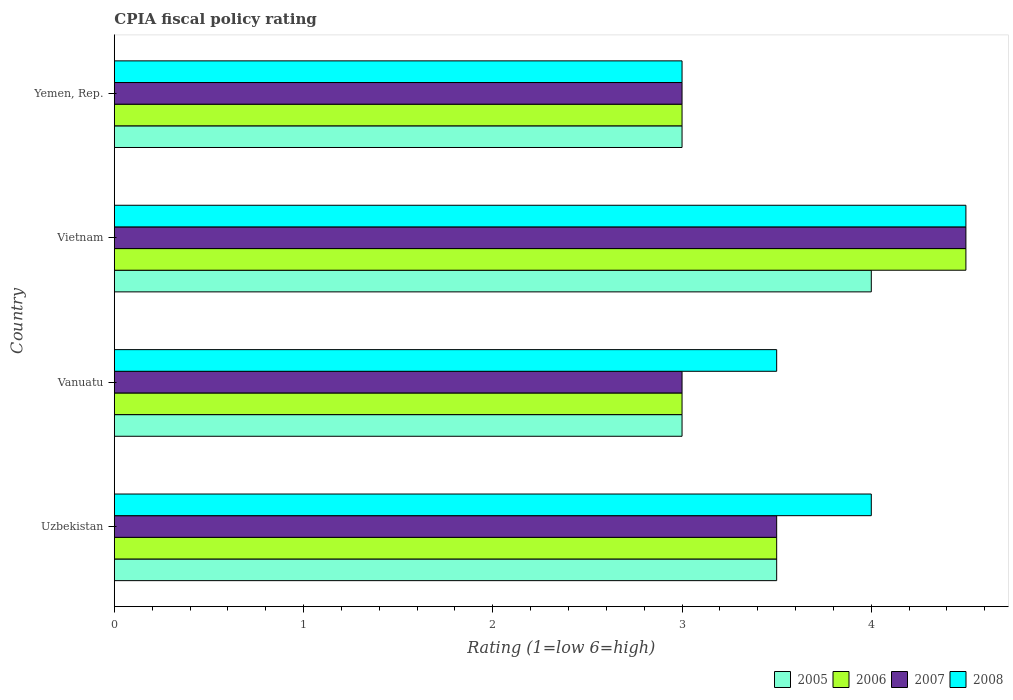How many groups of bars are there?
Make the answer very short. 4. How many bars are there on the 2nd tick from the top?
Your answer should be very brief. 4. How many bars are there on the 1st tick from the bottom?
Offer a very short reply. 4. What is the label of the 3rd group of bars from the top?
Offer a very short reply. Vanuatu. What is the CPIA rating in 2006 in Uzbekistan?
Keep it short and to the point. 3.5. Across all countries, what is the maximum CPIA rating in 2007?
Make the answer very short. 4.5. In which country was the CPIA rating in 2006 maximum?
Give a very brief answer. Vietnam. In which country was the CPIA rating in 2007 minimum?
Your response must be concise. Vanuatu. What is the difference between the CPIA rating in 2008 in Uzbekistan and the CPIA rating in 2006 in Vanuatu?
Make the answer very short. 1. What is the difference between the CPIA rating in 2005 and CPIA rating in 2008 in Vanuatu?
Provide a succinct answer. -0.5. What is the ratio of the CPIA rating in 2007 in Vanuatu to that in Yemen, Rep.?
Make the answer very short. 1. Is the CPIA rating in 2005 in Uzbekistan less than that in Yemen, Rep.?
Your answer should be very brief. No. Is the difference between the CPIA rating in 2005 in Uzbekistan and Yemen, Rep. greater than the difference between the CPIA rating in 2008 in Uzbekistan and Yemen, Rep.?
Make the answer very short. No. In how many countries, is the CPIA rating in 2005 greater than the average CPIA rating in 2005 taken over all countries?
Offer a terse response. 2. Is the sum of the CPIA rating in 2008 in Vanuatu and Vietnam greater than the maximum CPIA rating in 2006 across all countries?
Offer a terse response. Yes. Is it the case that in every country, the sum of the CPIA rating in 2007 and CPIA rating in 2006 is greater than the sum of CPIA rating in 2005 and CPIA rating in 2008?
Your answer should be compact. No. What does the 4th bar from the bottom in Vanuatu represents?
Ensure brevity in your answer.  2008. How many bars are there?
Offer a terse response. 16. Are all the bars in the graph horizontal?
Your response must be concise. Yes. How many countries are there in the graph?
Your answer should be very brief. 4. Does the graph contain any zero values?
Offer a very short reply. No. Does the graph contain grids?
Provide a succinct answer. No. Where does the legend appear in the graph?
Your answer should be compact. Bottom right. How are the legend labels stacked?
Give a very brief answer. Horizontal. What is the title of the graph?
Your response must be concise. CPIA fiscal policy rating. Does "1983" appear as one of the legend labels in the graph?
Your answer should be very brief. No. What is the label or title of the X-axis?
Your answer should be compact. Rating (1=low 6=high). What is the Rating (1=low 6=high) of 2005 in Uzbekistan?
Give a very brief answer. 3.5. What is the Rating (1=low 6=high) of 2005 in Vanuatu?
Give a very brief answer. 3. What is the Rating (1=low 6=high) in 2008 in Vanuatu?
Your answer should be compact. 3.5. What is the Rating (1=low 6=high) of 2007 in Vietnam?
Provide a short and direct response. 4.5. What is the Rating (1=low 6=high) of 2005 in Yemen, Rep.?
Ensure brevity in your answer.  3. What is the Rating (1=low 6=high) of 2007 in Yemen, Rep.?
Make the answer very short. 3. What is the Rating (1=low 6=high) of 2008 in Yemen, Rep.?
Provide a succinct answer. 3. Across all countries, what is the maximum Rating (1=low 6=high) of 2008?
Give a very brief answer. 4.5. Across all countries, what is the minimum Rating (1=low 6=high) in 2006?
Provide a succinct answer. 3. Across all countries, what is the minimum Rating (1=low 6=high) of 2007?
Give a very brief answer. 3. What is the total Rating (1=low 6=high) in 2005 in the graph?
Give a very brief answer. 13.5. What is the total Rating (1=low 6=high) in 2006 in the graph?
Offer a terse response. 14. What is the total Rating (1=low 6=high) in 2007 in the graph?
Offer a very short reply. 14. What is the difference between the Rating (1=low 6=high) in 2005 in Uzbekistan and that in Vanuatu?
Ensure brevity in your answer.  0.5. What is the difference between the Rating (1=low 6=high) in 2006 in Uzbekistan and that in Vanuatu?
Your response must be concise. 0.5. What is the difference between the Rating (1=low 6=high) in 2008 in Uzbekistan and that in Vanuatu?
Offer a terse response. 0.5. What is the difference between the Rating (1=low 6=high) of 2005 in Uzbekistan and that in Vietnam?
Keep it short and to the point. -0.5. What is the difference between the Rating (1=low 6=high) of 2007 in Uzbekistan and that in Vietnam?
Your answer should be very brief. -1. What is the difference between the Rating (1=low 6=high) of 2008 in Uzbekistan and that in Vietnam?
Provide a short and direct response. -0.5. What is the difference between the Rating (1=low 6=high) of 2005 in Uzbekistan and that in Yemen, Rep.?
Ensure brevity in your answer.  0.5. What is the difference between the Rating (1=low 6=high) of 2006 in Uzbekistan and that in Yemen, Rep.?
Your answer should be very brief. 0.5. What is the difference between the Rating (1=low 6=high) of 2007 in Uzbekistan and that in Yemen, Rep.?
Give a very brief answer. 0.5. What is the difference between the Rating (1=low 6=high) in 2005 in Vanuatu and that in Yemen, Rep.?
Your answer should be very brief. 0. What is the difference between the Rating (1=low 6=high) in 2006 in Vanuatu and that in Yemen, Rep.?
Provide a succinct answer. 0. What is the difference between the Rating (1=low 6=high) in 2007 in Vanuatu and that in Yemen, Rep.?
Your answer should be very brief. 0. What is the difference between the Rating (1=low 6=high) of 2005 in Vietnam and that in Yemen, Rep.?
Your response must be concise. 1. What is the difference between the Rating (1=low 6=high) in 2006 in Vietnam and that in Yemen, Rep.?
Give a very brief answer. 1.5. What is the difference between the Rating (1=low 6=high) in 2007 in Vietnam and that in Yemen, Rep.?
Your answer should be compact. 1.5. What is the difference between the Rating (1=low 6=high) of 2005 in Uzbekistan and the Rating (1=low 6=high) of 2006 in Vanuatu?
Make the answer very short. 0.5. What is the difference between the Rating (1=low 6=high) in 2005 in Uzbekistan and the Rating (1=low 6=high) in 2008 in Vanuatu?
Keep it short and to the point. 0. What is the difference between the Rating (1=low 6=high) in 2006 in Uzbekistan and the Rating (1=low 6=high) in 2008 in Vanuatu?
Ensure brevity in your answer.  0. What is the difference between the Rating (1=low 6=high) in 2007 in Uzbekistan and the Rating (1=low 6=high) in 2008 in Vanuatu?
Provide a short and direct response. 0. What is the difference between the Rating (1=low 6=high) of 2005 in Uzbekistan and the Rating (1=low 6=high) of 2008 in Vietnam?
Provide a short and direct response. -1. What is the difference between the Rating (1=low 6=high) of 2006 in Uzbekistan and the Rating (1=low 6=high) of 2007 in Vietnam?
Your response must be concise. -1. What is the difference between the Rating (1=low 6=high) in 2005 in Uzbekistan and the Rating (1=low 6=high) in 2006 in Yemen, Rep.?
Keep it short and to the point. 0.5. What is the difference between the Rating (1=low 6=high) in 2005 in Uzbekistan and the Rating (1=low 6=high) in 2007 in Yemen, Rep.?
Provide a short and direct response. 0.5. What is the difference between the Rating (1=low 6=high) of 2005 in Uzbekistan and the Rating (1=low 6=high) of 2008 in Yemen, Rep.?
Keep it short and to the point. 0.5. What is the difference between the Rating (1=low 6=high) in 2006 in Uzbekistan and the Rating (1=low 6=high) in 2007 in Yemen, Rep.?
Your answer should be very brief. 0.5. What is the difference between the Rating (1=low 6=high) of 2005 in Vanuatu and the Rating (1=low 6=high) of 2007 in Vietnam?
Offer a terse response. -1.5. What is the difference between the Rating (1=low 6=high) of 2005 in Vanuatu and the Rating (1=low 6=high) of 2008 in Vietnam?
Keep it short and to the point. -1.5. What is the difference between the Rating (1=low 6=high) of 2006 in Vanuatu and the Rating (1=low 6=high) of 2007 in Vietnam?
Provide a short and direct response. -1.5. What is the difference between the Rating (1=low 6=high) in 2006 in Vanuatu and the Rating (1=low 6=high) in 2008 in Vietnam?
Give a very brief answer. -1.5. What is the difference between the Rating (1=low 6=high) in 2007 in Vanuatu and the Rating (1=low 6=high) in 2008 in Vietnam?
Offer a very short reply. -1.5. What is the difference between the Rating (1=low 6=high) in 2005 in Vanuatu and the Rating (1=low 6=high) in 2007 in Yemen, Rep.?
Keep it short and to the point. 0. What is the difference between the Rating (1=low 6=high) in 2005 in Vanuatu and the Rating (1=low 6=high) in 2008 in Yemen, Rep.?
Your answer should be very brief. 0. What is the difference between the Rating (1=low 6=high) in 2006 in Vanuatu and the Rating (1=low 6=high) in 2007 in Yemen, Rep.?
Provide a short and direct response. 0. What is the difference between the Rating (1=low 6=high) of 2006 in Vanuatu and the Rating (1=low 6=high) of 2008 in Yemen, Rep.?
Give a very brief answer. 0. What is the difference between the Rating (1=low 6=high) of 2007 in Vanuatu and the Rating (1=low 6=high) of 2008 in Yemen, Rep.?
Give a very brief answer. 0. What is the difference between the Rating (1=low 6=high) in 2005 in Vietnam and the Rating (1=low 6=high) in 2006 in Yemen, Rep.?
Provide a succinct answer. 1. What is the difference between the Rating (1=low 6=high) in 2005 in Vietnam and the Rating (1=low 6=high) in 2008 in Yemen, Rep.?
Offer a terse response. 1. What is the average Rating (1=low 6=high) in 2005 per country?
Ensure brevity in your answer.  3.38. What is the average Rating (1=low 6=high) of 2008 per country?
Offer a terse response. 3.75. What is the difference between the Rating (1=low 6=high) in 2005 and Rating (1=low 6=high) in 2006 in Uzbekistan?
Make the answer very short. 0. What is the difference between the Rating (1=low 6=high) in 2007 and Rating (1=low 6=high) in 2008 in Uzbekistan?
Your response must be concise. -0.5. What is the difference between the Rating (1=low 6=high) of 2005 and Rating (1=low 6=high) of 2007 in Vanuatu?
Your answer should be compact. 0. What is the difference between the Rating (1=low 6=high) in 2005 and Rating (1=low 6=high) in 2008 in Vanuatu?
Offer a terse response. -0.5. What is the difference between the Rating (1=low 6=high) of 2007 and Rating (1=low 6=high) of 2008 in Vanuatu?
Offer a very short reply. -0.5. What is the difference between the Rating (1=low 6=high) in 2005 and Rating (1=low 6=high) in 2006 in Vietnam?
Offer a terse response. -0.5. What is the difference between the Rating (1=low 6=high) in 2005 and Rating (1=low 6=high) in 2006 in Yemen, Rep.?
Your answer should be compact. 0. What is the difference between the Rating (1=low 6=high) of 2005 and Rating (1=low 6=high) of 2007 in Yemen, Rep.?
Provide a succinct answer. 0. What is the difference between the Rating (1=low 6=high) of 2005 and Rating (1=low 6=high) of 2008 in Yemen, Rep.?
Your answer should be compact. 0. What is the difference between the Rating (1=low 6=high) of 2006 and Rating (1=low 6=high) of 2007 in Yemen, Rep.?
Provide a short and direct response. 0. What is the ratio of the Rating (1=low 6=high) in 2005 in Uzbekistan to that in Vanuatu?
Offer a terse response. 1.17. What is the ratio of the Rating (1=low 6=high) of 2006 in Uzbekistan to that in Vanuatu?
Your response must be concise. 1.17. What is the ratio of the Rating (1=low 6=high) in 2005 in Uzbekistan to that in Vietnam?
Keep it short and to the point. 0.88. What is the ratio of the Rating (1=low 6=high) of 2006 in Uzbekistan to that in Vietnam?
Offer a very short reply. 0.78. What is the ratio of the Rating (1=low 6=high) in 2005 in Uzbekistan to that in Yemen, Rep.?
Give a very brief answer. 1.17. What is the ratio of the Rating (1=low 6=high) in 2006 in Uzbekistan to that in Yemen, Rep.?
Your answer should be compact. 1.17. What is the ratio of the Rating (1=low 6=high) in 2008 in Uzbekistan to that in Yemen, Rep.?
Keep it short and to the point. 1.33. What is the ratio of the Rating (1=low 6=high) in 2006 in Vanuatu to that in Vietnam?
Give a very brief answer. 0.67. What is the ratio of the Rating (1=low 6=high) in 2007 in Vanuatu to that in Vietnam?
Provide a short and direct response. 0.67. What is the ratio of the Rating (1=low 6=high) of 2008 in Vanuatu to that in Vietnam?
Your answer should be compact. 0.78. What is the ratio of the Rating (1=low 6=high) in 2005 in Vanuatu to that in Yemen, Rep.?
Provide a short and direct response. 1. What is the ratio of the Rating (1=low 6=high) in 2006 in Vanuatu to that in Yemen, Rep.?
Offer a very short reply. 1. What is the ratio of the Rating (1=low 6=high) in 2005 in Vietnam to that in Yemen, Rep.?
Provide a short and direct response. 1.33. What is the ratio of the Rating (1=low 6=high) in 2007 in Vietnam to that in Yemen, Rep.?
Provide a succinct answer. 1.5. What is the difference between the highest and the second highest Rating (1=low 6=high) in 2007?
Make the answer very short. 1. What is the difference between the highest and the second highest Rating (1=low 6=high) of 2008?
Your answer should be compact. 0.5. What is the difference between the highest and the lowest Rating (1=low 6=high) of 2006?
Your answer should be compact. 1.5. What is the difference between the highest and the lowest Rating (1=low 6=high) in 2007?
Provide a succinct answer. 1.5. What is the difference between the highest and the lowest Rating (1=low 6=high) of 2008?
Give a very brief answer. 1.5. 